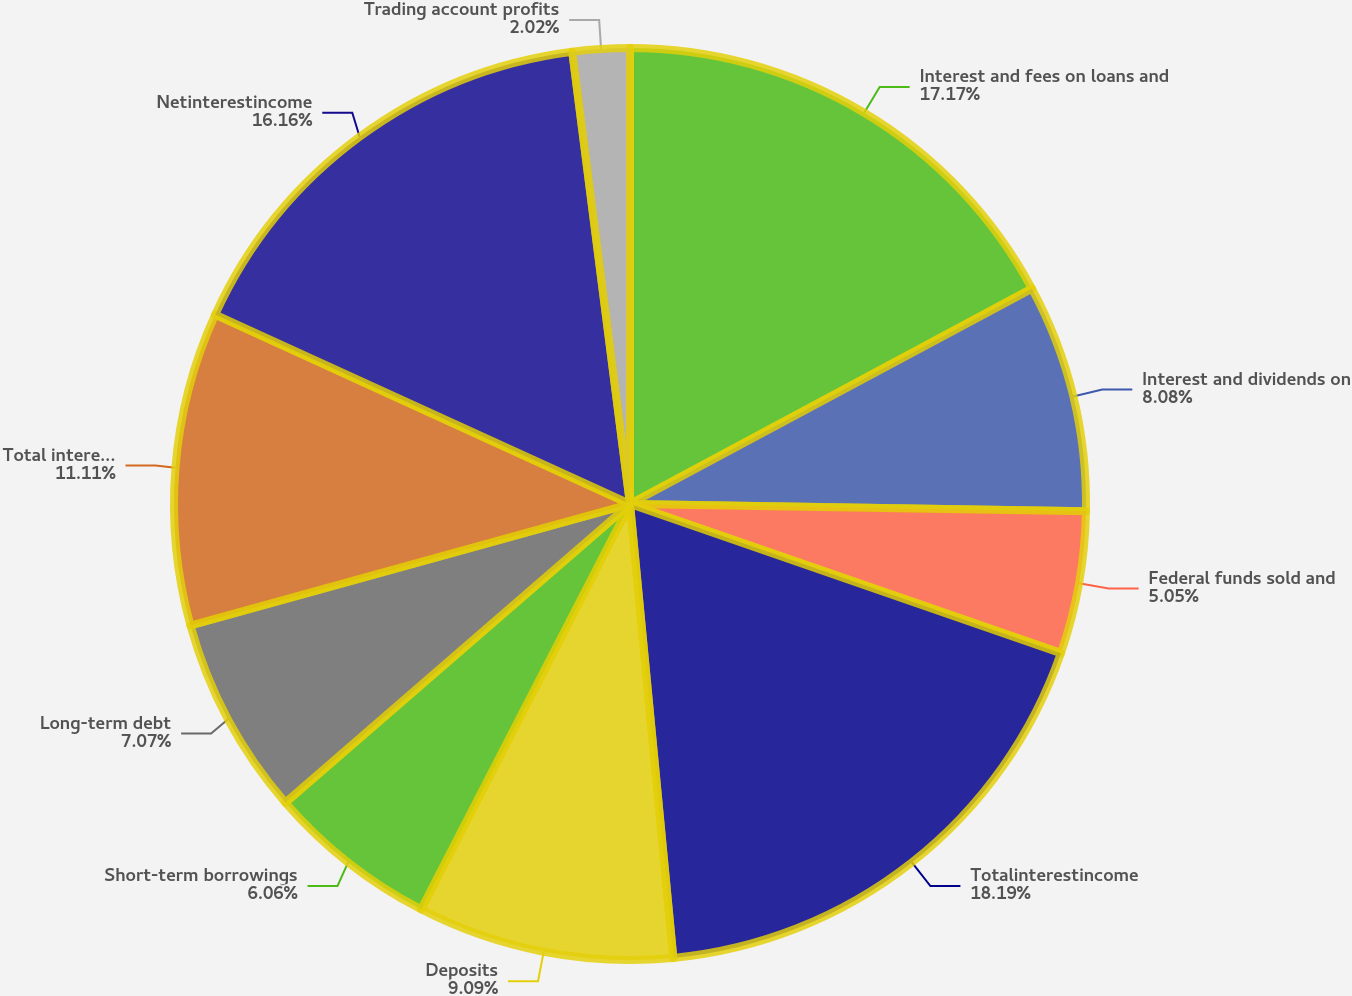Convert chart. <chart><loc_0><loc_0><loc_500><loc_500><pie_chart><fcel>Interest and fees on loans and<fcel>Interest and dividends on<fcel>Federal funds sold and<fcel>Totalinterestincome<fcel>Deposits<fcel>Short-term borrowings<fcel>Long-term debt<fcel>Total interest expense<fcel>Netinterestincome<fcel>Trading account profits<nl><fcel>17.17%<fcel>8.08%<fcel>5.05%<fcel>18.18%<fcel>9.09%<fcel>6.06%<fcel>7.07%<fcel>11.11%<fcel>16.16%<fcel>2.02%<nl></chart> 